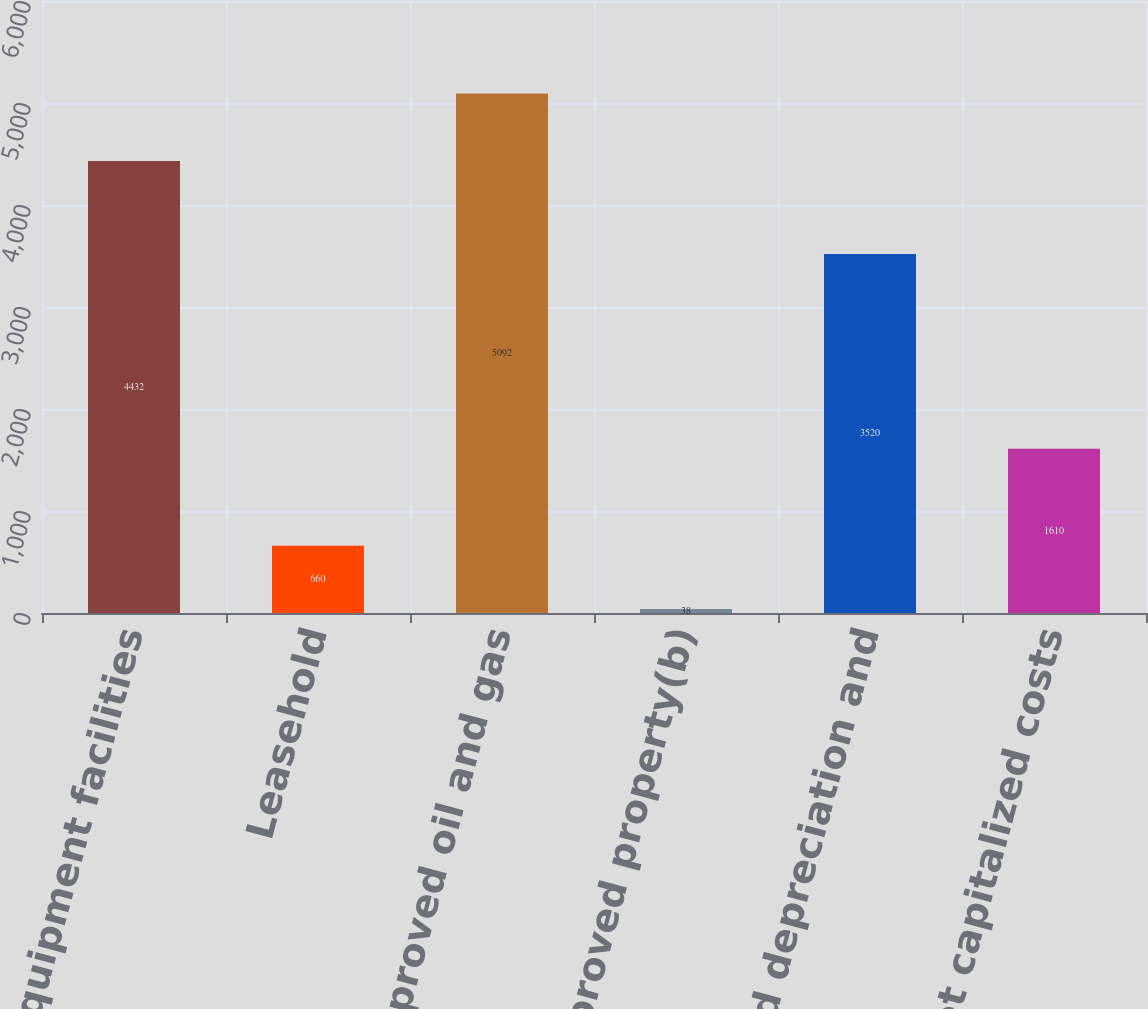<chart> <loc_0><loc_0><loc_500><loc_500><bar_chart><fcel>Wells and equipment facilities<fcel>Leasehold<fcel>Total proved oil and gas<fcel>Unproved property(b)<fcel>Accumulated depreciation and<fcel>Net capitalized costs<nl><fcel>4432<fcel>660<fcel>5092<fcel>38<fcel>3520<fcel>1610<nl></chart> 